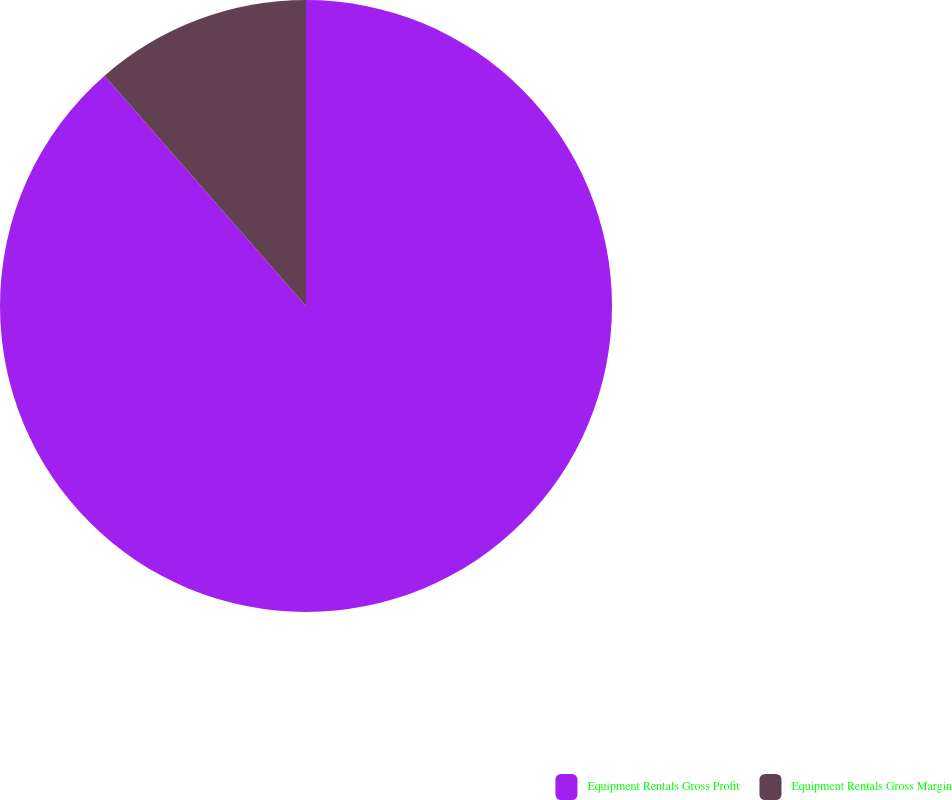Convert chart. <chart><loc_0><loc_0><loc_500><loc_500><pie_chart><fcel>Equipment Rentals Gross Profit<fcel>Equipment Rentals Gross Margin<nl><fcel>88.56%<fcel>11.44%<nl></chart> 